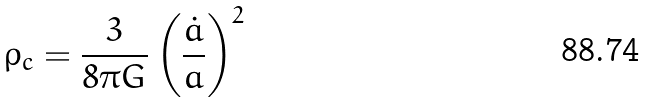Convert formula to latex. <formula><loc_0><loc_0><loc_500><loc_500>\rho _ { c } = \frac { 3 } { 8 \pi G } \left ( \frac { \dot { a } } { a } \right ) ^ { 2 }</formula> 